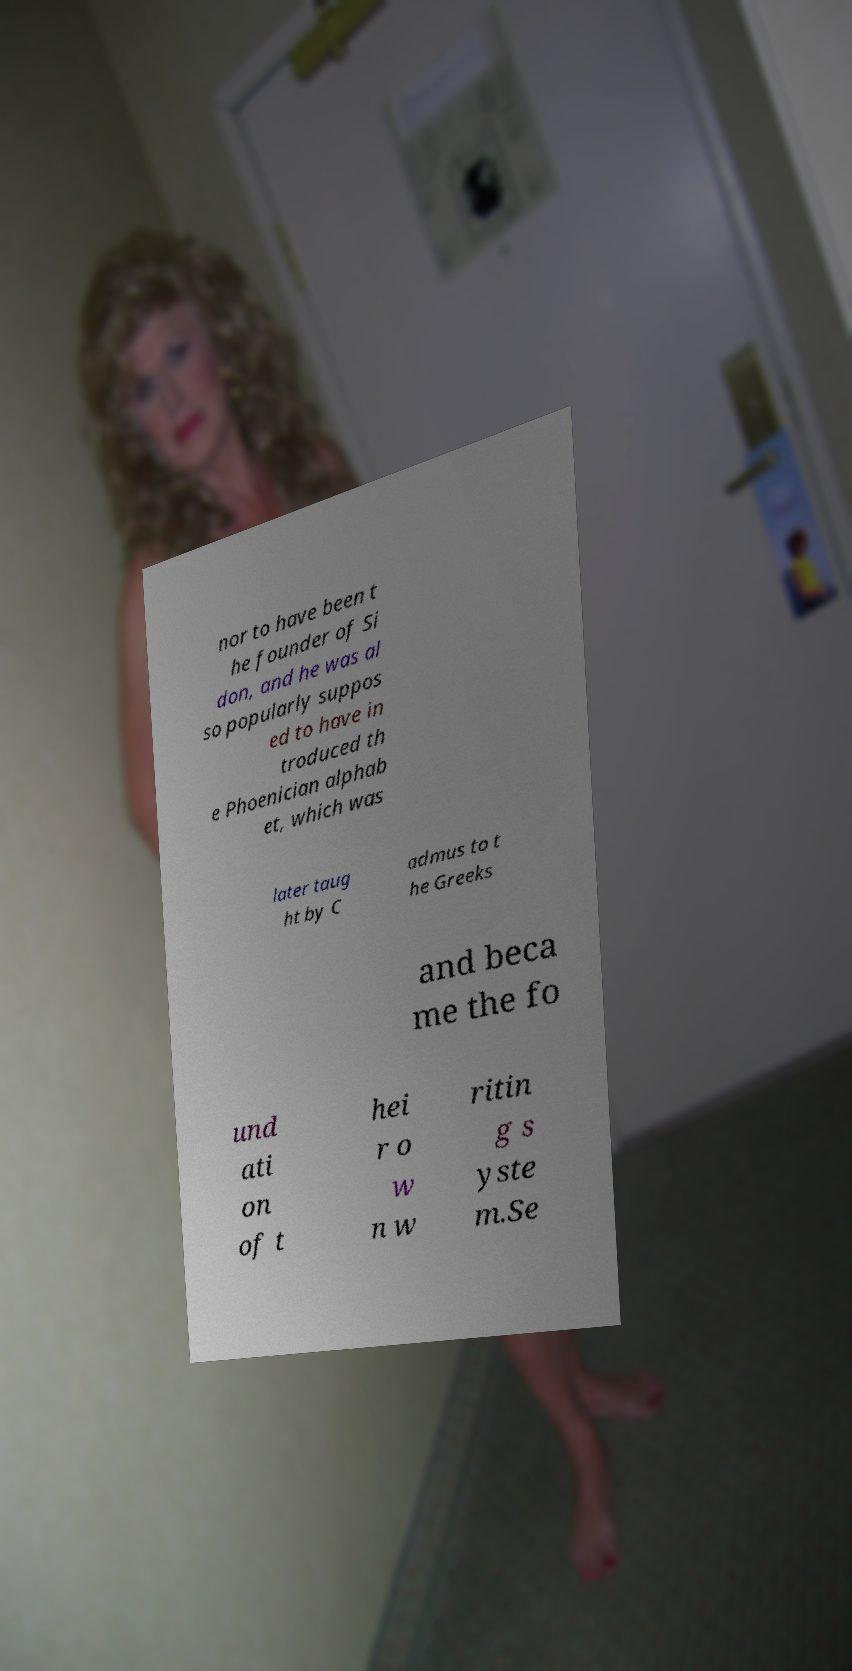Please read and relay the text visible in this image. What does it say? nor to have been t he founder of Si don, and he was al so popularly suppos ed to have in troduced th e Phoenician alphab et, which was later taug ht by C admus to t he Greeks and beca me the fo und ati on of t hei r o w n w ritin g s yste m.Se 